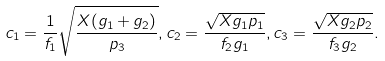<formula> <loc_0><loc_0><loc_500><loc_500>c _ { 1 } = \frac { 1 } { f _ { 1 } } \sqrt { \frac { X ( g _ { 1 } + g _ { 2 } ) } { p _ { 3 } } } , c _ { 2 } = \frac { \sqrt { X g _ { 1 } p _ { 1 } } } { f _ { 2 } g _ { 1 } } , c _ { 3 } = \frac { \sqrt { X g _ { 2 } p _ { 2 } } } { f _ { 3 } g _ { 2 } } .</formula> 